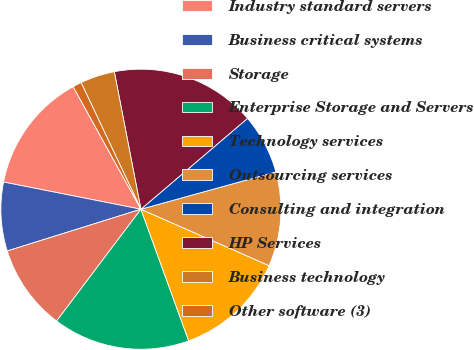<chart> <loc_0><loc_0><loc_500><loc_500><pie_chart><fcel>Industry standard servers<fcel>Business critical systems<fcel>Storage<fcel>Enterprise Storage and Servers<fcel>Technology services<fcel>Outsourcing services<fcel>Consulting and integration<fcel>HP Services<fcel>Business technology<fcel>Other software (3)<nl><fcel>13.85%<fcel>7.93%<fcel>9.9%<fcel>15.82%<fcel>12.86%<fcel>10.89%<fcel>6.94%<fcel>16.81%<fcel>3.98%<fcel>1.02%<nl></chart> 